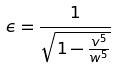<formula> <loc_0><loc_0><loc_500><loc_500>\epsilon = \frac { 1 } { \sqrt { 1 - \frac { v ^ { 5 } } { w ^ { 5 } } } }</formula> 